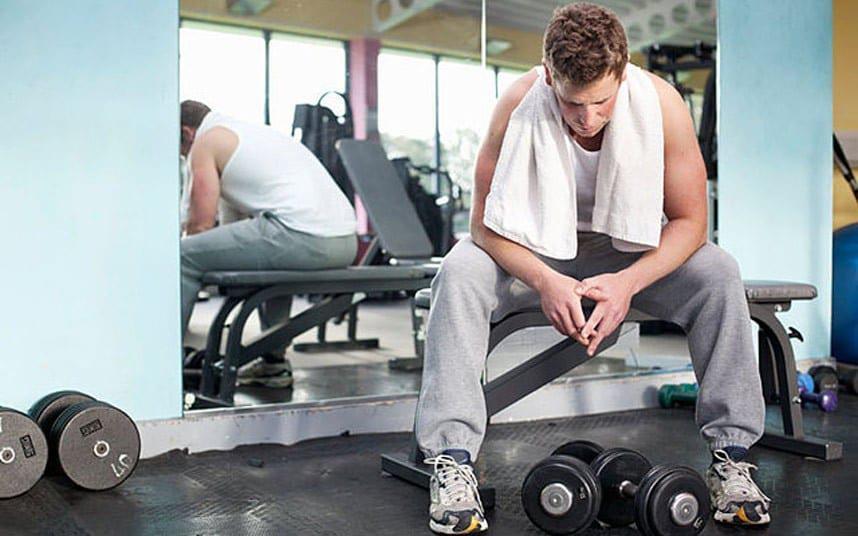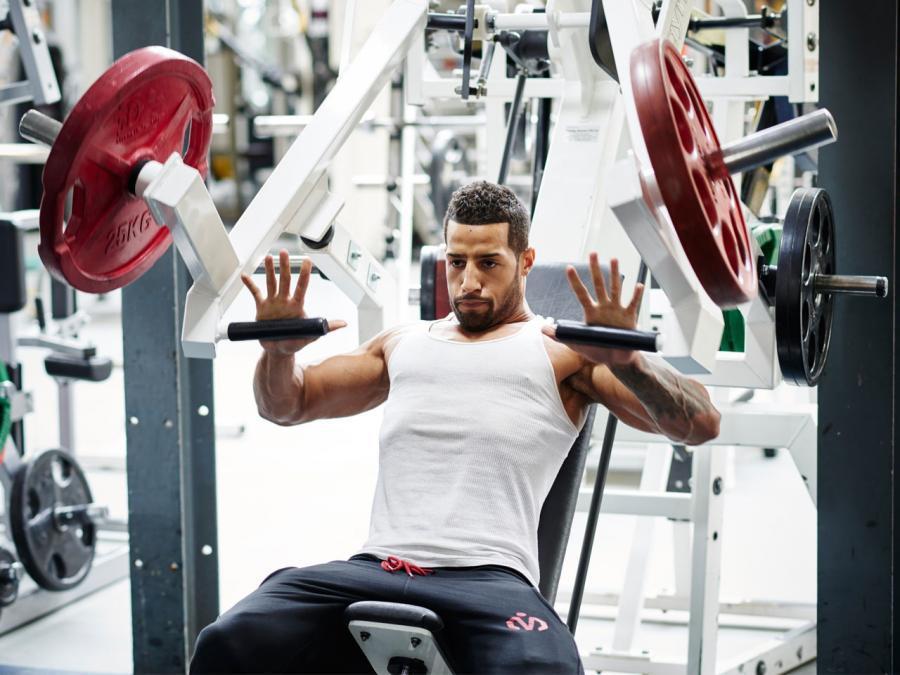The first image is the image on the left, the second image is the image on the right. For the images shown, is this caption "An image shows a man grasping weights and facing the floor, with body extended horizontally plank-style." true? Answer yes or no. No. The first image is the image on the left, the second image is the image on the right. Examine the images to the left and right. Is the description "In one image a bodybuilder, facing the floor, is balanced on the toes of his feet and has at least one hand on the floor gripping a small barbell." accurate? Answer yes or no. No. 